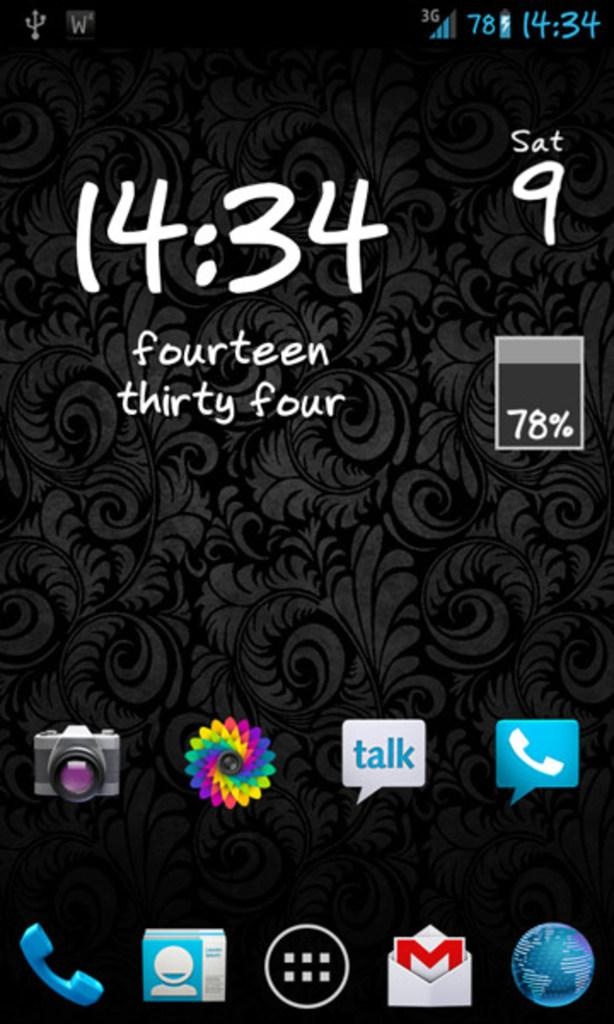<image>
Relay a brief, clear account of the picture shown. A phone screen displays the time of 14:34. 